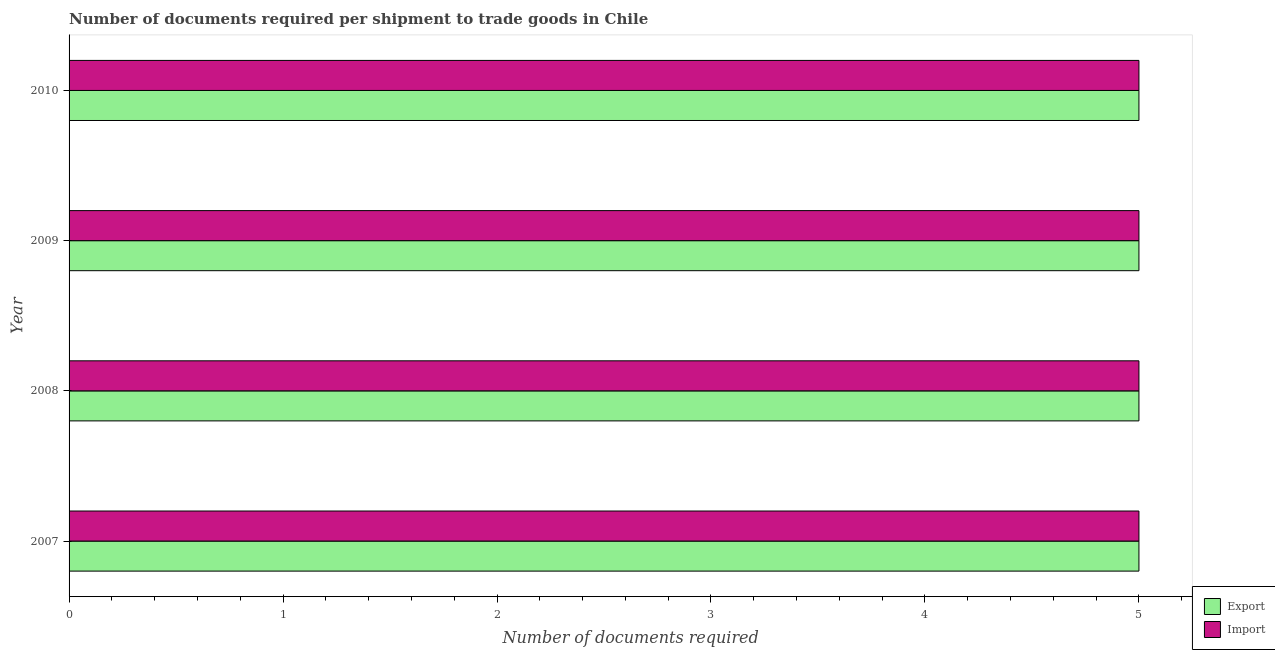How many groups of bars are there?
Provide a succinct answer. 4. Are the number of bars on each tick of the Y-axis equal?
Offer a very short reply. Yes. How many bars are there on the 2nd tick from the top?
Give a very brief answer. 2. In how many cases, is the number of bars for a given year not equal to the number of legend labels?
Offer a very short reply. 0. What is the number of documents required to import goods in 2010?
Offer a terse response. 5. Across all years, what is the maximum number of documents required to import goods?
Make the answer very short. 5. Across all years, what is the minimum number of documents required to export goods?
Keep it short and to the point. 5. In which year was the number of documents required to import goods minimum?
Your answer should be compact. 2007. What is the total number of documents required to import goods in the graph?
Ensure brevity in your answer.  20. What is the average number of documents required to export goods per year?
Offer a terse response. 5. In the year 2007, what is the difference between the number of documents required to import goods and number of documents required to export goods?
Ensure brevity in your answer.  0. What is the ratio of the number of documents required to import goods in 2007 to that in 2009?
Offer a very short reply. 1. Is the number of documents required to import goods in 2007 less than that in 2010?
Ensure brevity in your answer.  No. What is the difference between the highest and the lowest number of documents required to export goods?
Make the answer very short. 0. Is the sum of the number of documents required to import goods in 2007 and 2010 greater than the maximum number of documents required to export goods across all years?
Offer a terse response. Yes. What does the 2nd bar from the top in 2009 represents?
Ensure brevity in your answer.  Export. What does the 2nd bar from the bottom in 2008 represents?
Provide a succinct answer. Import. Does the graph contain any zero values?
Ensure brevity in your answer.  No. Does the graph contain grids?
Offer a very short reply. No. Where does the legend appear in the graph?
Your answer should be very brief. Bottom right. How many legend labels are there?
Your response must be concise. 2. What is the title of the graph?
Your response must be concise. Number of documents required per shipment to trade goods in Chile. What is the label or title of the X-axis?
Keep it short and to the point. Number of documents required. What is the Number of documents required of Export in 2007?
Give a very brief answer. 5. What is the Number of documents required in Import in 2007?
Offer a terse response. 5. What is the Number of documents required of Export in 2009?
Provide a succinct answer. 5. What is the Number of documents required in Import in 2009?
Keep it short and to the point. 5. Across all years, what is the maximum Number of documents required in Export?
Provide a short and direct response. 5. Across all years, what is the maximum Number of documents required in Import?
Offer a terse response. 5. Across all years, what is the minimum Number of documents required of Export?
Make the answer very short. 5. Across all years, what is the minimum Number of documents required in Import?
Your answer should be very brief. 5. What is the total Number of documents required in Export in the graph?
Your answer should be compact. 20. What is the difference between the Number of documents required in Export in 2007 and that in 2008?
Provide a short and direct response. 0. What is the difference between the Number of documents required in Import in 2007 and that in 2008?
Provide a short and direct response. 0. What is the difference between the Number of documents required of Export in 2007 and that in 2009?
Offer a very short reply. 0. What is the difference between the Number of documents required of Export in 2007 and that in 2010?
Your answer should be compact. 0. What is the difference between the Number of documents required of Import in 2008 and that in 2009?
Offer a terse response. 0. What is the difference between the Number of documents required of Export in 2008 and that in 2010?
Provide a succinct answer. 0. What is the difference between the Number of documents required in Import in 2008 and that in 2010?
Offer a terse response. 0. What is the difference between the Number of documents required of Import in 2009 and that in 2010?
Ensure brevity in your answer.  0. What is the difference between the Number of documents required in Export in 2007 and the Number of documents required in Import in 2009?
Make the answer very short. 0. What is the difference between the Number of documents required of Export in 2007 and the Number of documents required of Import in 2010?
Your answer should be compact. 0. What is the difference between the Number of documents required of Export in 2009 and the Number of documents required of Import in 2010?
Offer a very short reply. 0. What is the average Number of documents required in Export per year?
Make the answer very short. 5. In the year 2007, what is the difference between the Number of documents required in Export and Number of documents required in Import?
Offer a very short reply. 0. In the year 2008, what is the difference between the Number of documents required of Export and Number of documents required of Import?
Your answer should be very brief. 0. In the year 2009, what is the difference between the Number of documents required in Export and Number of documents required in Import?
Your response must be concise. 0. In the year 2010, what is the difference between the Number of documents required of Export and Number of documents required of Import?
Ensure brevity in your answer.  0. What is the ratio of the Number of documents required in Import in 2007 to that in 2008?
Provide a short and direct response. 1. What is the ratio of the Number of documents required of Import in 2008 to that in 2009?
Make the answer very short. 1. What is the ratio of the Number of documents required of Export in 2008 to that in 2010?
Keep it short and to the point. 1. What is the ratio of the Number of documents required in Import in 2008 to that in 2010?
Offer a very short reply. 1. What is the ratio of the Number of documents required in Export in 2009 to that in 2010?
Keep it short and to the point. 1. What is the ratio of the Number of documents required in Import in 2009 to that in 2010?
Provide a succinct answer. 1. What is the difference between the highest and the second highest Number of documents required of Import?
Offer a terse response. 0. What is the difference between the highest and the lowest Number of documents required of Import?
Offer a very short reply. 0. 